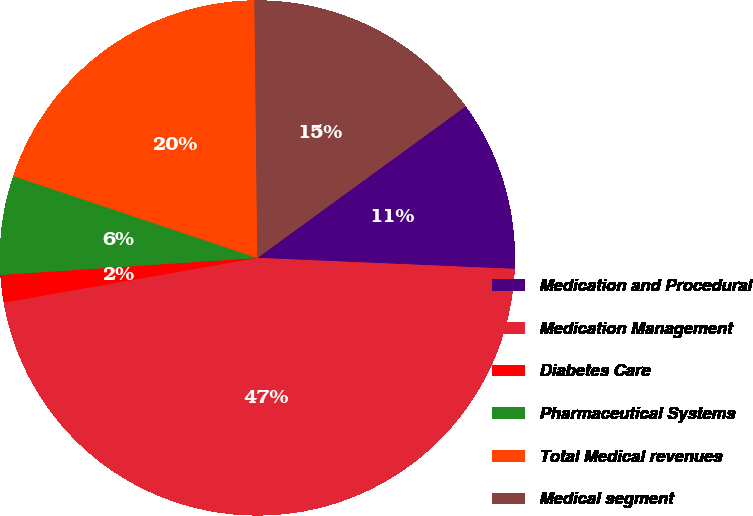Convert chart. <chart><loc_0><loc_0><loc_500><loc_500><pie_chart><fcel>Medication and Procedural<fcel>Medication Management<fcel>Diabetes Care<fcel>Pharmaceutical Systems<fcel>Total Medical revenues<fcel>Medical segment<nl><fcel>10.69%<fcel>46.55%<fcel>1.72%<fcel>6.21%<fcel>19.66%<fcel>15.17%<nl></chart> 